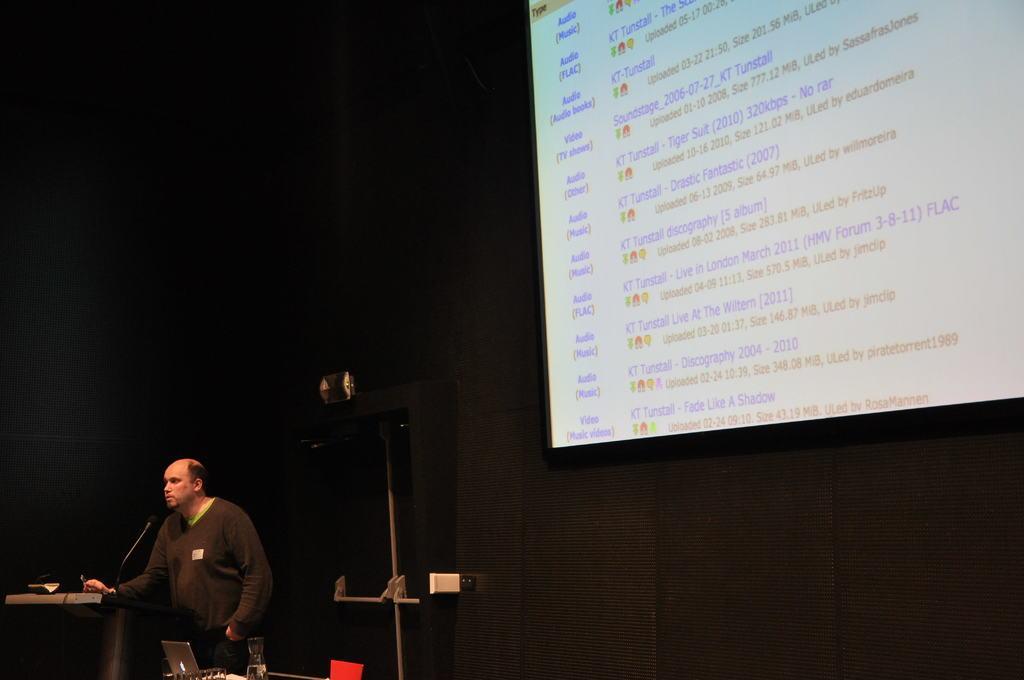Describe this image in one or two sentences. In the bottom left corner of the image there is a table, on the table there are some laptops, glasses and microphone. Behind them a person is standing. In the bottom right corner of the image there is wall, on the wall there is a screen. 